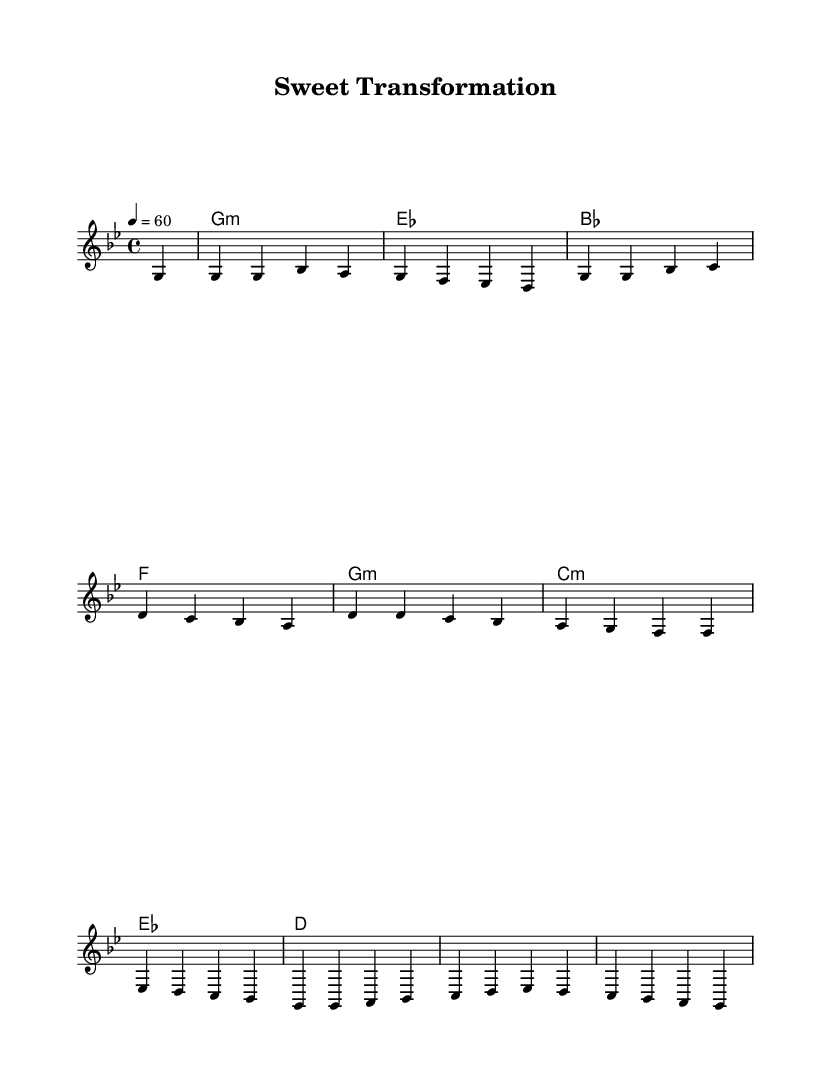What is the key signature of this music? The key signature is G minor, which has two flats. This can be identified by looking at the beginning of the staff where the key signature symbols are placed.
Answer: G minor What is the time signature of this music? The time signature is 4/4. This is shown at the beginning of the music, indicating there are four beats per measure and a quarter note receives one beat.
Answer: 4/4 What is the tempo marking for this piece? The tempo marking is 60 beats per minute. This is indicated next to the tempo instruction at the start of the piece, referring to how quickly the song should be played.
Answer: 60 How many measures are in the melody section? The melody section consists of eight measures. By counting the vertical lines that separate the sections in the sheet music, we can determine the total number of measures provided in the melody part.
Answer: Eight What is the tonic chord in this piece? The tonic chord is G minor. This is the chord identified based on the first harmonies shown in the chord progression at the beginning, which lists G minor as the first chord followed by other harmonies.
Answer: G minor What kind of emotional journey might this ballad explore? This ballad likely explores themes of personal transformation and emotional depth based on the characteristics of soulful ballads, which often focus on lived experiences and inner growth, directly tied to the arranged melodies and harmonies that evoke feelings.
Answer: Personal transformation 